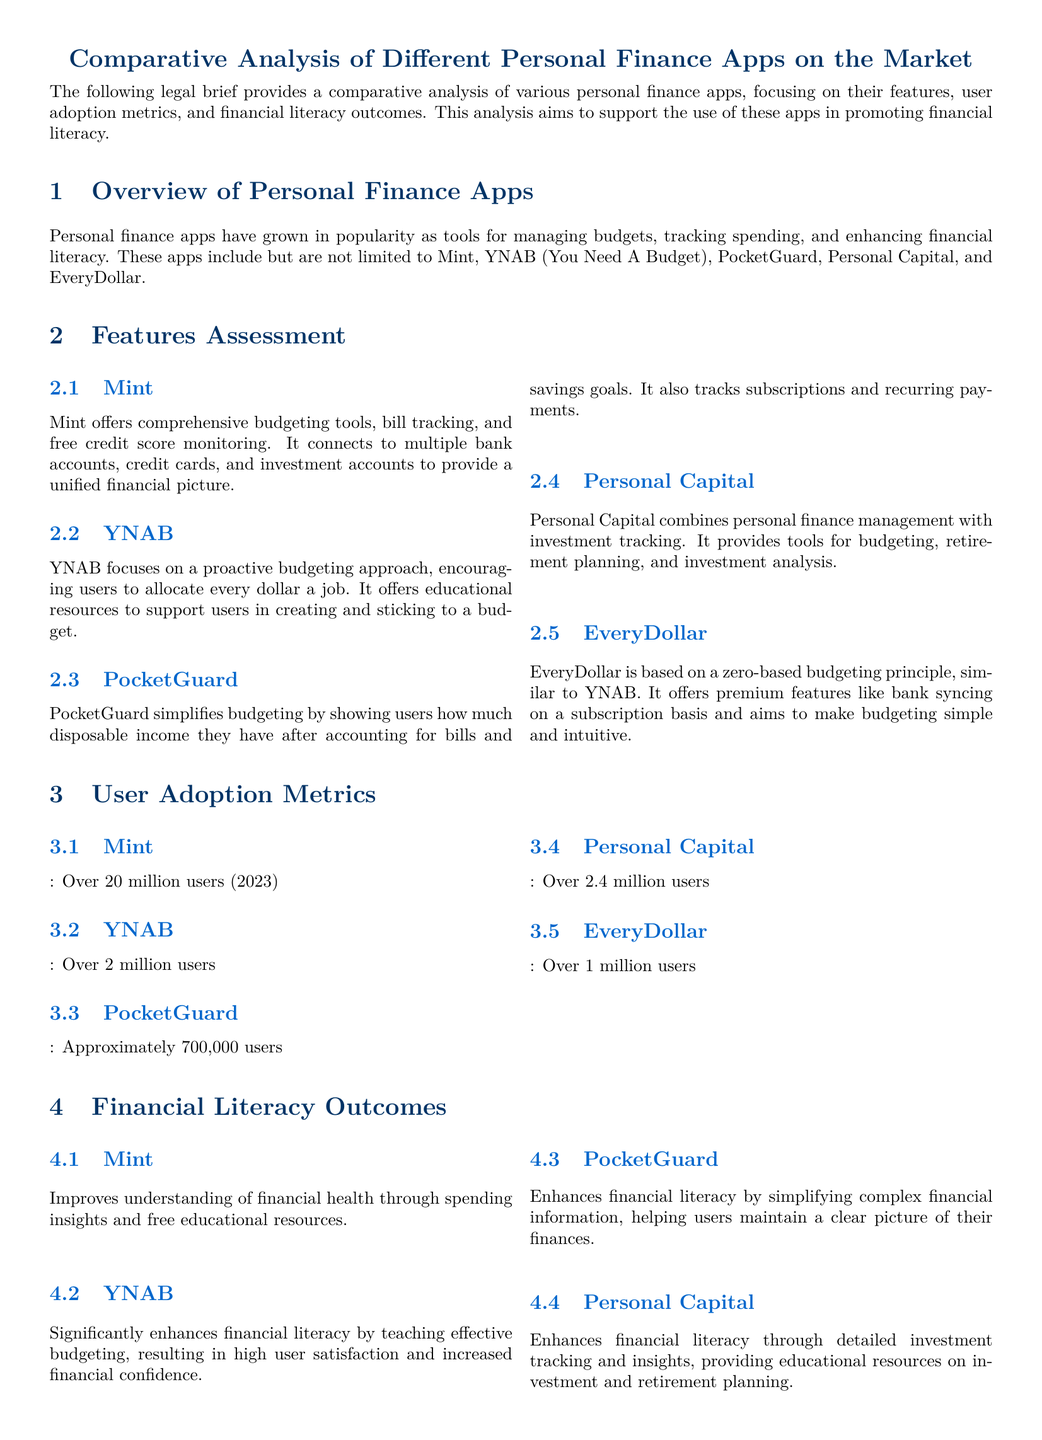What is the primary purpose of the legal brief? The primary purpose of the legal brief is to provide a comparative analysis of various personal finance apps, focusing on their features, user adoption metrics, and financial literacy outcomes.
Answer: comparative analysis of various personal finance apps How many users does Mint have in 2023? The user adoption metric for Mint indicates over 20 million users in 2023.
Answer: over 20 million users Which app emphasizes a proactive budgeting approach? YNAB is the app that emphasizes a proactive budgeting approach, encouraging users to allocate every dollar a job.
Answer: YNAB What principle does EveryDollar use for budgeting? EveryDollar is based on a zero-based budgeting principle.
Answer: zero-based budgeting principle Which app combines personal finance management with investment tracking? Personal Capital combines personal finance management with investment tracking.
Answer: Personal Capital Which app offers tools for retirement planning? Personal Capital offers tools for retirement planning along with personal finance management.
Answer: Personal Capital How many users does PocketGuard approximately have? PocketGuard has approximately 700,000 users.
Answer: approximately 700,000 users What was the outcome of using YNAB according to the document? YNAB significantly enhances financial literacy by teaching effective budgeting, resulting in high user satisfaction and increased financial confidence.
Answer: significantly enhances financial literacy What is the conclusion about personal finance apps in the brief? The conclusion states that personal finance apps offer a variety of features and benefits that can significantly enhance financial literacy.
Answer: significantly enhance financial literacy 